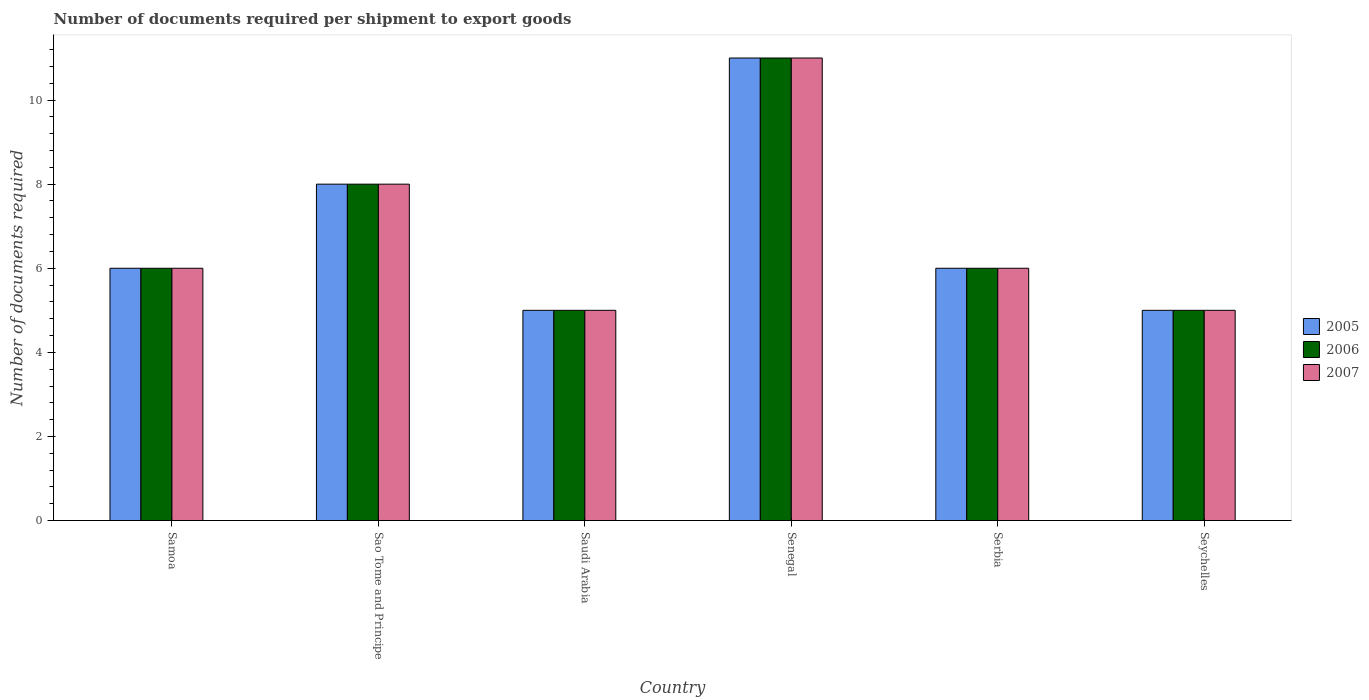How many different coloured bars are there?
Provide a succinct answer. 3. Are the number of bars per tick equal to the number of legend labels?
Provide a short and direct response. Yes. What is the label of the 2nd group of bars from the left?
Keep it short and to the point. Sao Tome and Principe. Across all countries, what is the maximum number of documents required per shipment to export goods in 2007?
Give a very brief answer. 11. Across all countries, what is the minimum number of documents required per shipment to export goods in 2005?
Ensure brevity in your answer.  5. In which country was the number of documents required per shipment to export goods in 2005 maximum?
Your response must be concise. Senegal. In which country was the number of documents required per shipment to export goods in 2005 minimum?
Provide a succinct answer. Saudi Arabia. What is the average number of documents required per shipment to export goods in 2005 per country?
Your answer should be very brief. 6.83. What is the difference between the number of documents required per shipment to export goods of/in 2005 and number of documents required per shipment to export goods of/in 2006 in Saudi Arabia?
Offer a terse response. 0. In how many countries, is the number of documents required per shipment to export goods in 2006 greater than 3.2?
Provide a short and direct response. 6. Is the number of documents required per shipment to export goods in 2006 in Sao Tome and Principe less than that in Senegal?
Your answer should be very brief. Yes. Is the difference between the number of documents required per shipment to export goods in 2005 in Senegal and Seychelles greater than the difference between the number of documents required per shipment to export goods in 2006 in Senegal and Seychelles?
Your response must be concise. No. What is the difference between the highest and the lowest number of documents required per shipment to export goods in 2007?
Your response must be concise. 6. In how many countries, is the number of documents required per shipment to export goods in 2006 greater than the average number of documents required per shipment to export goods in 2006 taken over all countries?
Offer a terse response. 2. Is the sum of the number of documents required per shipment to export goods in 2007 in Samoa and Seychelles greater than the maximum number of documents required per shipment to export goods in 2005 across all countries?
Provide a succinct answer. No. What does the 2nd bar from the right in Serbia represents?
Provide a succinct answer. 2006. Is it the case that in every country, the sum of the number of documents required per shipment to export goods in 2005 and number of documents required per shipment to export goods in 2006 is greater than the number of documents required per shipment to export goods in 2007?
Ensure brevity in your answer.  Yes. How many bars are there?
Provide a short and direct response. 18. Are all the bars in the graph horizontal?
Provide a succinct answer. No. How many countries are there in the graph?
Make the answer very short. 6. Does the graph contain any zero values?
Your answer should be compact. No. Does the graph contain grids?
Make the answer very short. No. Where does the legend appear in the graph?
Provide a short and direct response. Center right. How many legend labels are there?
Make the answer very short. 3. What is the title of the graph?
Provide a short and direct response. Number of documents required per shipment to export goods. Does "1986" appear as one of the legend labels in the graph?
Offer a very short reply. No. What is the label or title of the X-axis?
Ensure brevity in your answer.  Country. What is the label or title of the Y-axis?
Ensure brevity in your answer.  Number of documents required. What is the Number of documents required of 2006 in Samoa?
Offer a terse response. 6. What is the Number of documents required in 2005 in Saudi Arabia?
Provide a short and direct response. 5. What is the Number of documents required in 2006 in Saudi Arabia?
Ensure brevity in your answer.  5. What is the Number of documents required of 2007 in Senegal?
Keep it short and to the point. 11. What is the Number of documents required of 2005 in Serbia?
Your answer should be compact. 6. What is the Number of documents required of 2007 in Seychelles?
Offer a very short reply. 5. Across all countries, what is the maximum Number of documents required in 2007?
Provide a short and direct response. 11. Across all countries, what is the minimum Number of documents required in 2006?
Your answer should be compact. 5. Across all countries, what is the minimum Number of documents required of 2007?
Offer a terse response. 5. What is the total Number of documents required of 2006 in the graph?
Offer a very short reply. 41. What is the total Number of documents required in 2007 in the graph?
Ensure brevity in your answer.  41. What is the difference between the Number of documents required of 2005 in Samoa and that in Sao Tome and Principe?
Provide a succinct answer. -2. What is the difference between the Number of documents required in 2006 in Samoa and that in Sao Tome and Principe?
Make the answer very short. -2. What is the difference between the Number of documents required in 2007 in Samoa and that in Sao Tome and Principe?
Provide a succinct answer. -2. What is the difference between the Number of documents required in 2006 in Samoa and that in Saudi Arabia?
Make the answer very short. 1. What is the difference between the Number of documents required of 2007 in Samoa and that in Saudi Arabia?
Provide a short and direct response. 1. What is the difference between the Number of documents required of 2006 in Samoa and that in Serbia?
Your answer should be very brief. 0. What is the difference between the Number of documents required in 2006 in Samoa and that in Seychelles?
Offer a terse response. 1. What is the difference between the Number of documents required of 2007 in Samoa and that in Seychelles?
Offer a terse response. 1. What is the difference between the Number of documents required of 2005 in Sao Tome and Principe and that in Saudi Arabia?
Keep it short and to the point. 3. What is the difference between the Number of documents required of 2006 in Sao Tome and Principe and that in Saudi Arabia?
Give a very brief answer. 3. What is the difference between the Number of documents required in 2006 in Sao Tome and Principe and that in Serbia?
Make the answer very short. 2. What is the difference between the Number of documents required in 2005 in Sao Tome and Principe and that in Seychelles?
Offer a very short reply. 3. What is the difference between the Number of documents required of 2005 in Saudi Arabia and that in Serbia?
Your answer should be compact. -1. What is the difference between the Number of documents required in 2007 in Saudi Arabia and that in Seychelles?
Your answer should be very brief. 0. What is the difference between the Number of documents required of 2005 in Senegal and that in Serbia?
Ensure brevity in your answer.  5. What is the difference between the Number of documents required of 2006 in Senegal and that in Serbia?
Give a very brief answer. 5. What is the difference between the Number of documents required in 2005 in Samoa and the Number of documents required in 2006 in Sao Tome and Principe?
Your answer should be very brief. -2. What is the difference between the Number of documents required of 2006 in Samoa and the Number of documents required of 2007 in Sao Tome and Principe?
Offer a very short reply. -2. What is the difference between the Number of documents required in 2006 in Samoa and the Number of documents required in 2007 in Saudi Arabia?
Offer a very short reply. 1. What is the difference between the Number of documents required of 2005 in Samoa and the Number of documents required of 2007 in Senegal?
Your response must be concise. -5. What is the difference between the Number of documents required in 2006 in Samoa and the Number of documents required in 2007 in Senegal?
Offer a terse response. -5. What is the difference between the Number of documents required of 2005 in Samoa and the Number of documents required of 2006 in Serbia?
Ensure brevity in your answer.  0. What is the difference between the Number of documents required in 2005 in Samoa and the Number of documents required in 2007 in Serbia?
Make the answer very short. 0. What is the difference between the Number of documents required of 2006 in Samoa and the Number of documents required of 2007 in Serbia?
Provide a succinct answer. 0. What is the difference between the Number of documents required in 2005 in Samoa and the Number of documents required in 2007 in Seychelles?
Provide a succinct answer. 1. What is the difference between the Number of documents required in 2005 in Sao Tome and Principe and the Number of documents required in 2006 in Saudi Arabia?
Keep it short and to the point. 3. What is the difference between the Number of documents required of 2005 in Sao Tome and Principe and the Number of documents required of 2006 in Senegal?
Provide a succinct answer. -3. What is the difference between the Number of documents required in 2006 in Sao Tome and Principe and the Number of documents required in 2007 in Senegal?
Your answer should be very brief. -3. What is the difference between the Number of documents required of 2005 in Sao Tome and Principe and the Number of documents required of 2007 in Seychelles?
Give a very brief answer. 3. What is the difference between the Number of documents required in 2005 in Saudi Arabia and the Number of documents required in 2006 in Senegal?
Give a very brief answer. -6. What is the difference between the Number of documents required in 2005 in Saudi Arabia and the Number of documents required in 2007 in Senegal?
Offer a very short reply. -6. What is the difference between the Number of documents required of 2006 in Saudi Arabia and the Number of documents required of 2007 in Senegal?
Give a very brief answer. -6. What is the difference between the Number of documents required in 2005 in Saudi Arabia and the Number of documents required in 2006 in Serbia?
Your response must be concise. -1. What is the difference between the Number of documents required of 2005 in Saudi Arabia and the Number of documents required of 2007 in Serbia?
Give a very brief answer. -1. What is the difference between the Number of documents required of 2005 in Saudi Arabia and the Number of documents required of 2006 in Seychelles?
Keep it short and to the point. 0. What is the difference between the Number of documents required of 2005 in Saudi Arabia and the Number of documents required of 2007 in Seychelles?
Your response must be concise. 0. What is the difference between the Number of documents required in 2006 in Saudi Arabia and the Number of documents required in 2007 in Seychelles?
Ensure brevity in your answer.  0. What is the difference between the Number of documents required of 2006 in Serbia and the Number of documents required of 2007 in Seychelles?
Your response must be concise. 1. What is the average Number of documents required in 2005 per country?
Give a very brief answer. 6.83. What is the average Number of documents required of 2006 per country?
Keep it short and to the point. 6.83. What is the average Number of documents required in 2007 per country?
Give a very brief answer. 6.83. What is the difference between the Number of documents required of 2005 and Number of documents required of 2006 in Samoa?
Give a very brief answer. 0. What is the difference between the Number of documents required in 2005 and Number of documents required in 2007 in Samoa?
Provide a short and direct response. 0. What is the difference between the Number of documents required in 2006 and Number of documents required in 2007 in Sao Tome and Principe?
Offer a very short reply. 0. What is the difference between the Number of documents required in 2005 and Number of documents required in 2006 in Saudi Arabia?
Provide a short and direct response. 0. What is the difference between the Number of documents required of 2005 and Number of documents required of 2007 in Saudi Arabia?
Make the answer very short. 0. What is the difference between the Number of documents required of 2005 and Number of documents required of 2007 in Serbia?
Give a very brief answer. 0. What is the difference between the Number of documents required of 2005 and Number of documents required of 2006 in Seychelles?
Keep it short and to the point. 0. What is the difference between the Number of documents required in 2006 and Number of documents required in 2007 in Seychelles?
Your answer should be very brief. 0. What is the ratio of the Number of documents required in 2007 in Samoa to that in Sao Tome and Principe?
Your answer should be compact. 0.75. What is the ratio of the Number of documents required in 2005 in Samoa to that in Senegal?
Ensure brevity in your answer.  0.55. What is the ratio of the Number of documents required of 2006 in Samoa to that in Senegal?
Ensure brevity in your answer.  0.55. What is the ratio of the Number of documents required of 2007 in Samoa to that in Senegal?
Keep it short and to the point. 0.55. What is the ratio of the Number of documents required in 2005 in Samoa to that in Serbia?
Your response must be concise. 1. What is the ratio of the Number of documents required in 2006 in Sao Tome and Principe to that in Saudi Arabia?
Give a very brief answer. 1.6. What is the ratio of the Number of documents required in 2005 in Sao Tome and Principe to that in Senegal?
Provide a short and direct response. 0.73. What is the ratio of the Number of documents required of 2006 in Sao Tome and Principe to that in Senegal?
Provide a succinct answer. 0.73. What is the ratio of the Number of documents required in 2007 in Sao Tome and Principe to that in Senegal?
Provide a succinct answer. 0.73. What is the ratio of the Number of documents required of 2005 in Sao Tome and Principe to that in Serbia?
Keep it short and to the point. 1.33. What is the ratio of the Number of documents required in 2006 in Sao Tome and Principe to that in Serbia?
Give a very brief answer. 1.33. What is the ratio of the Number of documents required of 2007 in Sao Tome and Principe to that in Serbia?
Your response must be concise. 1.33. What is the ratio of the Number of documents required of 2006 in Sao Tome and Principe to that in Seychelles?
Provide a succinct answer. 1.6. What is the ratio of the Number of documents required in 2007 in Sao Tome and Principe to that in Seychelles?
Give a very brief answer. 1.6. What is the ratio of the Number of documents required of 2005 in Saudi Arabia to that in Senegal?
Keep it short and to the point. 0.45. What is the ratio of the Number of documents required in 2006 in Saudi Arabia to that in Senegal?
Your answer should be very brief. 0.45. What is the ratio of the Number of documents required of 2007 in Saudi Arabia to that in Senegal?
Your response must be concise. 0.45. What is the ratio of the Number of documents required of 2005 in Saudi Arabia to that in Serbia?
Offer a terse response. 0.83. What is the ratio of the Number of documents required of 2006 in Saudi Arabia to that in Serbia?
Give a very brief answer. 0.83. What is the ratio of the Number of documents required of 2007 in Saudi Arabia to that in Serbia?
Your answer should be very brief. 0.83. What is the ratio of the Number of documents required in 2005 in Saudi Arabia to that in Seychelles?
Your answer should be very brief. 1. What is the ratio of the Number of documents required in 2006 in Saudi Arabia to that in Seychelles?
Make the answer very short. 1. What is the ratio of the Number of documents required of 2007 in Saudi Arabia to that in Seychelles?
Provide a succinct answer. 1. What is the ratio of the Number of documents required of 2005 in Senegal to that in Serbia?
Your response must be concise. 1.83. What is the ratio of the Number of documents required in 2006 in Senegal to that in Serbia?
Provide a succinct answer. 1.83. What is the ratio of the Number of documents required in 2007 in Senegal to that in Serbia?
Your answer should be compact. 1.83. What is the ratio of the Number of documents required of 2007 in Senegal to that in Seychelles?
Give a very brief answer. 2.2. What is the ratio of the Number of documents required of 2005 in Serbia to that in Seychelles?
Keep it short and to the point. 1.2. What is the ratio of the Number of documents required in 2006 in Serbia to that in Seychelles?
Your answer should be compact. 1.2. What is the ratio of the Number of documents required of 2007 in Serbia to that in Seychelles?
Your response must be concise. 1.2. What is the difference between the highest and the second highest Number of documents required of 2005?
Keep it short and to the point. 3. What is the difference between the highest and the lowest Number of documents required of 2005?
Keep it short and to the point. 6. What is the difference between the highest and the lowest Number of documents required of 2006?
Your answer should be compact. 6. What is the difference between the highest and the lowest Number of documents required in 2007?
Your response must be concise. 6. 